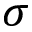<formula> <loc_0><loc_0><loc_500><loc_500>\sigma</formula> 